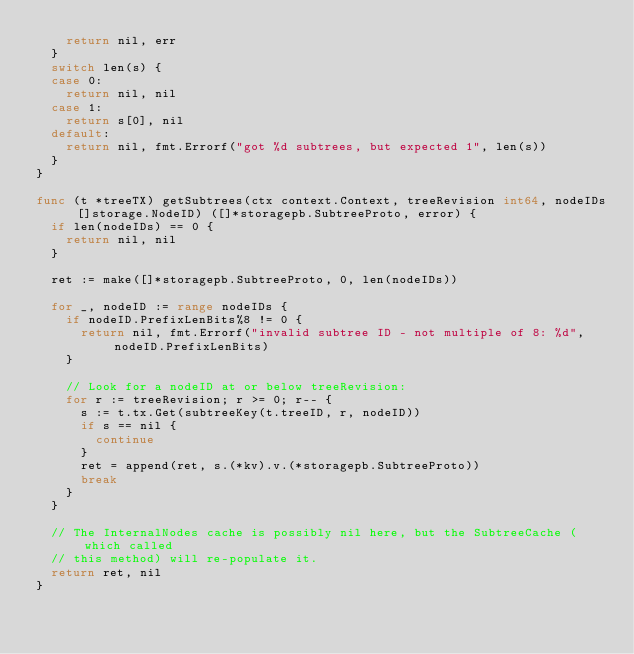Convert code to text. <code><loc_0><loc_0><loc_500><loc_500><_Go_>		return nil, err
	}
	switch len(s) {
	case 0:
		return nil, nil
	case 1:
		return s[0], nil
	default:
		return nil, fmt.Errorf("got %d subtrees, but expected 1", len(s))
	}
}

func (t *treeTX) getSubtrees(ctx context.Context, treeRevision int64, nodeIDs []storage.NodeID) ([]*storagepb.SubtreeProto, error) {
	if len(nodeIDs) == 0 {
		return nil, nil
	}

	ret := make([]*storagepb.SubtreeProto, 0, len(nodeIDs))

	for _, nodeID := range nodeIDs {
		if nodeID.PrefixLenBits%8 != 0 {
			return nil, fmt.Errorf("invalid subtree ID - not multiple of 8: %d", nodeID.PrefixLenBits)
		}

		// Look for a nodeID at or below treeRevision:
		for r := treeRevision; r >= 0; r-- {
			s := t.tx.Get(subtreeKey(t.treeID, r, nodeID))
			if s == nil {
				continue
			}
			ret = append(ret, s.(*kv).v.(*storagepb.SubtreeProto))
			break
		}
	}

	// The InternalNodes cache is possibly nil here, but the SubtreeCache (which called
	// this method) will re-populate it.
	return ret, nil
}
</code> 